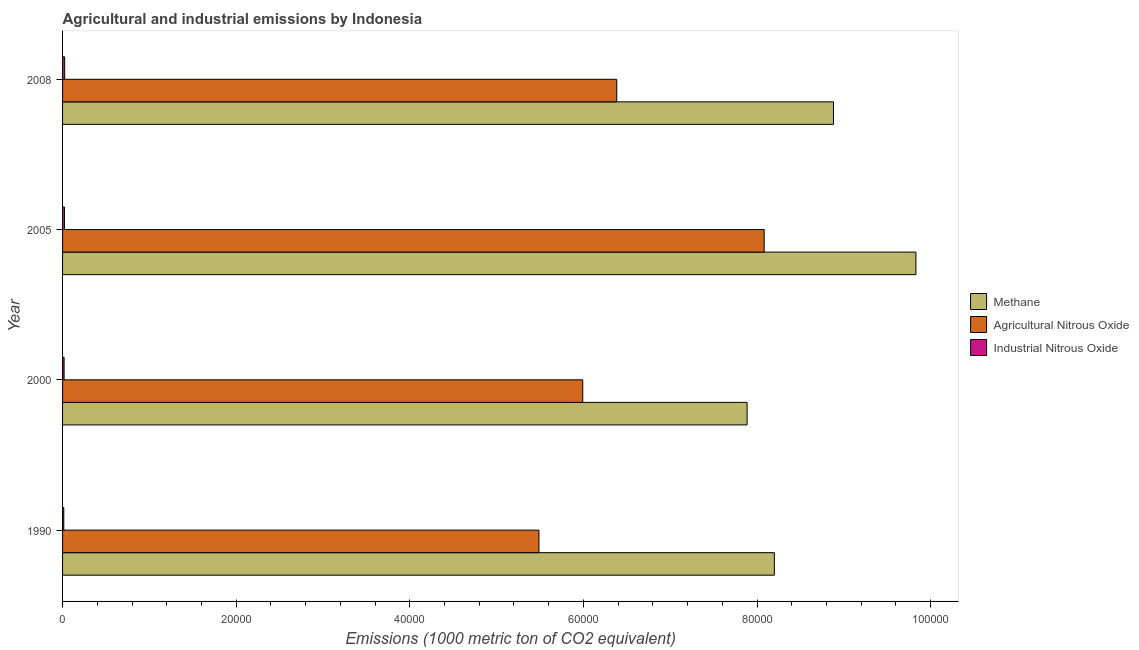How many bars are there on the 3rd tick from the top?
Offer a very short reply. 3. How many bars are there on the 2nd tick from the bottom?
Provide a succinct answer. 3. What is the amount of methane emissions in 2008?
Your answer should be very brief. 8.88e+04. Across all years, what is the maximum amount of industrial nitrous oxide emissions?
Keep it short and to the point. 243.3. Across all years, what is the minimum amount of industrial nitrous oxide emissions?
Make the answer very short. 139.5. In which year was the amount of methane emissions minimum?
Your answer should be very brief. 2000. What is the total amount of methane emissions in the graph?
Your response must be concise. 3.48e+05. What is the difference between the amount of methane emissions in 2000 and that in 2008?
Provide a succinct answer. -9950.5. What is the difference between the amount of agricultural nitrous oxide emissions in 2000 and the amount of industrial nitrous oxide emissions in 2008?
Give a very brief answer. 5.97e+04. What is the average amount of methane emissions per year?
Your answer should be compact. 8.70e+04. In the year 2005, what is the difference between the amount of agricultural nitrous oxide emissions and amount of industrial nitrous oxide emissions?
Provide a short and direct response. 8.06e+04. In how many years, is the amount of methane emissions greater than 76000 metric ton?
Your response must be concise. 4. What is the ratio of the amount of methane emissions in 2000 to that in 2008?
Your answer should be very brief. 0.89. What is the difference between the highest and the second highest amount of industrial nitrous oxide emissions?
Your answer should be compact. 23.7. What is the difference between the highest and the lowest amount of industrial nitrous oxide emissions?
Provide a succinct answer. 103.8. In how many years, is the amount of agricultural nitrous oxide emissions greater than the average amount of agricultural nitrous oxide emissions taken over all years?
Ensure brevity in your answer.  1. Is the sum of the amount of industrial nitrous oxide emissions in 2000 and 2008 greater than the maximum amount of methane emissions across all years?
Offer a terse response. No. What does the 2nd bar from the top in 2005 represents?
Your response must be concise. Agricultural Nitrous Oxide. What does the 3rd bar from the bottom in 2005 represents?
Provide a short and direct response. Industrial Nitrous Oxide. How many years are there in the graph?
Your answer should be compact. 4. Where does the legend appear in the graph?
Give a very brief answer. Center right. What is the title of the graph?
Make the answer very short. Agricultural and industrial emissions by Indonesia. What is the label or title of the X-axis?
Provide a short and direct response. Emissions (1000 metric ton of CO2 equivalent). What is the Emissions (1000 metric ton of CO2 equivalent) of Methane in 1990?
Keep it short and to the point. 8.20e+04. What is the Emissions (1000 metric ton of CO2 equivalent) of Agricultural Nitrous Oxide in 1990?
Your answer should be compact. 5.49e+04. What is the Emissions (1000 metric ton of CO2 equivalent) in Industrial Nitrous Oxide in 1990?
Offer a terse response. 139.5. What is the Emissions (1000 metric ton of CO2 equivalent) in Methane in 2000?
Provide a short and direct response. 7.89e+04. What is the Emissions (1000 metric ton of CO2 equivalent) in Agricultural Nitrous Oxide in 2000?
Offer a terse response. 5.99e+04. What is the Emissions (1000 metric ton of CO2 equivalent) in Industrial Nitrous Oxide in 2000?
Your response must be concise. 175.8. What is the Emissions (1000 metric ton of CO2 equivalent) in Methane in 2005?
Keep it short and to the point. 9.83e+04. What is the Emissions (1000 metric ton of CO2 equivalent) in Agricultural Nitrous Oxide in 2005?
Provide a succinct answer. 8.08e+04. What is the Emissions (1000 metric ton of CO2 equivalent) of Industrial Nitrous Oxide in 2005?
Keep it short and to the point. 219.6. What is the Emissions (1000 metric ton of CO2 equivalent) in Methane in 2008?
Provide a succinct answer. 8.88e+04. What is the Emissions (1000 metric ton of CO2 equivalent) of Agricultural Nitrous Oxide in 2008?
Keep it short and to the point. 6.38e+04. What is the Emissions (1000 metric ton of CO2 equivalent) of Industrial Nitrous Oxide in 2008?
Your answer should be very brief. 243.3. Across all years, what is the maximum Emissions (1000 metric ton of CO2 equivalent) in Methane?
Your answer should be compact. 9.83e+04. Across all years, what is the maximum Emissions (1000 metric ton of CO2 equivalent) of Agricultural Nitrous Oxide?
Give a very brief answer. 8.08e+04. Across all years, what is the maximum Emissions (1000 metric ton of CO2 equivalent) in Industrial Nitrous Oxide?
Provide a short and direct response. 243.3. Across all years, what is the minimum Emissions (1000 metric ton of CO2 equivalent) of Methane?
Provide a short and direct response. 7.89e+04. Across all years, what is the minimum Emissions (1000 metric ton of CO2 equivalent) of Agricultural Nitrous Oxide?
Offer a very short reply. 5.49e+04. Across all years, what is the minimum Emissions (1000 metric ton of CO2 equivalent) of Industrial Nitrous Oxide?
Make the answer very short. 139.5. What is the total Emissions (1000 metric ton of CO2 equivalent) in Methane in the graph?
Give a very brief answer. 3.48e+05. What is the total Emissions (1000 metric ton of CO2 equivalent) of Agricultural Nitrous Oxide in the graph?
Your response must be concise. 2.59e+05. What is the total Emissions (1000 metric ton of CO2 equivalent) in Industrial Nitrous Oxide in the graph?
Make the answer very short. 778.2. What is the difference between the Emissions (1000 metric ton of CO2 equivalent) in Methane in 1990 and that in 2000?
Make the answer very short. 3136.2. What is the difference between the Emissions (1000 metric ton of CO2 equivalent) in Agricultural Nitrous Oxide in 1990 and that in 2000?
Give a very brief answer. -5044.7. What is the difference between the Emissions (1000 metric ton of CO2 equivalent) of Industrial Nitrous Oxide in 1990 and that in 2000?
Provide a succinct answer. -36.3. What is the difference between the Emissions (1000 metric ton of CO2 equivalent) of Methane in 1990 and that in 2005?
Make the answer very short. -1.63e+04. What is the difference between the Emissions (1000 metric ton of CO2 equivalent) of Agricultural Nitrous Oxide in 1990 and that in 2005?
Offer a terse response. -2.59e+04. What is the difference between the Emissions (1000 metric ton of CO2 equivalent) of Industrial Nitrous Oxide in 1990 and that in 2005?
Your response must be concise. -80.1. What is the difference between the Emissions (1000 metric ton of CO2 equivalent) of Methane in 1990 and that in 2008?
Provide a succinct answer. -6814.3. What is the difference between the Emissions (1000 metric ton of CO2 equivalent) in Agricultural Nitrous Oxide in 1990 and that in 2008?
Keep it short and to the point. -8962.8. What is the difference between the Emissions (1000 metric ton of CO2 equivalent) of Industrial Nitrous Oxide in 1990 and that in 2008?
Offer a very short reply. -103.8. What is the difference between the Emissions (1000 metric ton of CO2 equivalent) of Methane in 2000 and that in 2005?
Make the answer very short. -1.94e+04. What is the difference between the Emissions (1000 metric ton of CO2 equivalent) of Agricultural Nitrous Oxide in 2000 and that in 2005?
Your answer should be compact. -2.09e+04. What is the difference between the Emissions (1000 metric ton of CO2 equivalent) of Industrial Nitrous Oxide in 2000 and that in 2005?
Your response must be concise. -43.8. What is the difference between the Emissions (1000 metric ton of CO2 equivalent) of Methane in 2000 and that in 2008?
Provide a succinct answer. -9950.5. What is the difference between the Emissions (1000 metric ton of CO2 equivalent) of Agricultural Nitrous Oxide in 2000 and that in 2008?
Your response must be concise. -3918.1. What is the difference between the Emissions (1000 metric ton of CO2 equivalent) of Industrial Nitrous Oxide in 2000 and that in 2008?
Give a very brief answer. -67.5. What is the difference between the Emissions (1000 metric ton of CO2 equivalent) in Methane in 2005 and that in 2008?
Make the answer very short. 9496.1. What is the difference between the Emissions (1000 metric ton of CO2 equivalent) of Agricultural Nitrous Oxide in 2005 and that in 2008?
Your answer should be very brief. 1.70e+04. What is the difference between the Emissions (1000 metric ton of CO2 equivalent) of Industrial Nitrous Oxide in 2005 and that in 2008?
Offer a very short reply. -23.7. What is the difference between the Emissions (1000 metric ton of CO2 equivalent) in Methane in 1990 and the Emissions (1000 metric ton of CO2 equivalent) in Agricultural Nitrous Oxide in 2000?
Offer a terse response. 2.21e+04. What is the difference between the Emissions (1000 metric ton of CO2 equivalent) of Methane in 1990 and the Emissions (1000 metric ton of CO2 equivalent) of Industrial Nitrous Oxide in 2000?
Provide a short and direct response. 8.18e+04. What is the difference between the Emissions (1000 metric ton of CO2 equivalent) in Agricultural Nitrous Oxide in 1990 and the Emissions (1000 metric ton of CO2 equivalent) in Industrial Nitrous Oxide in 2000?
Make the answer very short. 5.47e+04. What is the difference between the Emissions (1000 metric ton of CO2 equivalent) of Methane in 1990 and the Emissions (1000 metric ton of CO2 equivalent) of Agricultural Nitrous Oxide in 2005?
Provide a short and direct response. 1171.4. What is the difference between the Emissions (1000 metric ton of CO2 equivalent) of Methane in 1990 and the Emissions (1000 metric ton of CO2 equivalent) of Industrial Nitrous Oxide in 2005?
Keep it short and to the point. 8.18e+04. What is the difference between the Emissions (1000 metric ton of CO2 equivalent) of Agricultural Nitrous Oxide in 1990 and the Emissions (1000 metric ton of CO2 equivalent) of Industrial Nitrous Oxide in 2005?
Offer a very short reply. 5.47e+04. What is the difference between the Emissions (1000 metric ton of CO2 equivalent) of Methane in 1990 and the Emissions (1000 metric ton of CO2 equivalent) of Agricultural Nitrous Oxide in 2008?
Your answer should be very brief. 1.82e+04. What is the difference between the Emissions (1000 metric ton of CO2 equivalent) in Methane in 1990 and the Emissions (1000 metric ton of CO2 equivalent) in Industrial Nitrous Oxide in 2008?
Provide a short and direct response. 8.18e+04. What is the difference between the Emissions (1000 metric ton of CO2 equivalent) of Agricultural Nitrous Oxide in 1990 and the Emissions (1000 metric ton of CO2 equivalent) of Industrial Nitrous Oxide in 2008?
Provide a short and direct response. 5.46e+04. What is the difference between the Emissions (1000 metric ton of CO2 equivalent) in Methane in 2000 and the Emissions (1000 metric ton of CO2 equivalent) in Agricultural Nitrous Oxide in 2005?
Keep it short and to the point. -1964.8. What is the difference between the Emissions (1000 metric ton of CO2 equivalent) in Methane in 2000 and the Emissions (1000 metric ton of CO2 equivalent) in Industrial Nitrous Oxide in 2005?
Keep it short and to the point. 7.86e+04. What is the difference between the Emissions (1000 metric ton of CO2 equivalent) in Agricultural Nitrous Oxide in 2000 and the Emissions (1000 metric ton of CO2 equivalent) in Industrial Nitrous Oxide in 2005?
Provide a succinct answer. 5.97e+04. What is the difference between the Emissions (1000 metric ton of CO2 equivalent) in Methane in 2000 and the Emissions (1000 metric ton of CO2 equivalent) in Agricultural Nitrous Oxide in 2008?
Your answer should be very brief. 1.50e+04. What is the difference between the Emissions (1000 metric ton of CO2 equivalent) in Methane in 2000 and the Emissions (1000 metric ton of CO2 equivalent) in Industrial Nitrous Oxide in 2008?
Ensure brevity in your answer.  7.86e+04. What is the difference between the Emissions (1000 metric ton of CO2 equivalent) in Agricultural Nitrous Oxide in 2000 and the Emissions (1000 metric ton of CO2 equivalent) in Industrial Nitrous Oxide in 2008?
Your answer should be compact. 5.97e+04. What is the difference between the Emissions (1000 metric ton of CO2 equivalent) of Methane in 2005 and the Emissions (1000 metric ton of CO2 equivalent) of Agricultural Nitrous Oxide in 2008?
Your answer should be compact. 3.45e+04. What is the difference between the Emissions (1000 metric ton of CO2 equivalent) in Methane in 2005 and the Emissions (1000 metric ton of CO2 equivalent) in Industrial Nitrous Oxide in 2008?
Your answer should be compact. 9.81e+04. What is the difference between the Emissions (1000 metric ton of CO2 equivalent) in Agricultural Nitrous Oxide in 2005 and the Emissions (1000 metric ton of CO2 equivalent) in Industrial Nitrous Oxide in 2008?
Your response must be concise. 8.06e+04. What is the average Emissions (1000 metric ton of CO2 equivalent) of Methane per year?
Your answer should be very brief. 8.70e+04. What is the average Emissions (1000 metric ton of CO2 equivalent) of Agricultural Nitrous Oxide per year?
Provide a succinct answer. 6.49e+04. What is the average Emissions (1000 metric ton of CO2 equivalent) of Industrial Nitrous Oxide per year?
Provide a short and direct response. 194.55. In the year 1990, what is the difference between the Emissions (1000 metric ton of CO2 equivalent) in Methane and Emissions (1000 metric ton of CO2 equivalent) in Agricultural Nitrous Oxide?
Offer a very short reply. 2.71e+04. In the year 1990, what is the difference between the Emissions (1000 metric ton of CO2 equivalent) in Methane and Emissions (1000 metric ton of CO2 equivalent) in Industrial Nitrous Oxide?
Your answer should be compact. 8.19e+04. In the year 1990, what is the difference between the Emissions (1000 metric ton of CO2 equivalent) in Agricultural Nitrous Oxide and Emissions (1000 metric ton of CO2 equivalent) in Industrial Nitrous Oxide?
Provide a succinct answer. 5.47e+04. In the year 2000, what is the difference between the Emissions (1000 metric ton of CO2 equivalent) in Methane and Emissions (1000 metric ton of CO2 equivalent) in Agricultural Nitrous Oxide?
Make the answer very short. 1.89e+04. In the year 2000, what is the difference between the Emissions (1000 metric ton of CO2 equivalent) in Methane and Emissions (1000 metric ton of CO2 equivalent) in Industrial Nitrous Oxide?
Give a very brief answer. 7.87e+04. In the year 2000, what is the difference between the Emissions (1000 metric ton of CO2 equivalent) in Agricultural Nitrous Oxide and Emissions (1000 metric ton of CO2 equivalent) in Industrial Nitrous Oxide?
Offer a very short reply. 5.98e+04. In the year 2005, what is the difference between the Emissions (1000 metric ton of CO2 equivalent) of Methane and Emissions (1000 metric ton of CO2 equivalent) of Agricultural Nitrous Oxide?
Give a very brief answer. 1.75e+04. In the year 2005, what is the difference between the Emissions (1000 metric ton of CO2 equivalent) in Methane and Emissions (1000 metric ton of CO2 equivalent) in Industrial Nitrous Oxide?
Your response must be concise. 9.81e+04. In the year 2005, what is the difference between the Emissions (1000 metric ton of CO2 equivalent) of Agricultural Nitrous Oxide and Emissions (1000 metric ton of CO2 equivalent) of Industrial Nitrous Oxide?
Your answer should be compact. 8.06e+04. In the year 2008, what is the difference between the Emissions (1000 metric ton of CO2 equivalent) in Methane and Emissions (1000 metric ton of CO2 equivalent) in Agricultural Nitrous Oxide?
Give a very brief answer. 2.50e+04. In the year 2008, what is the difference between the Emissions (1000 metric ton of CO2 equivalent) of Methane and Emissions (1000 metric ton of CO2 equivalent) of Industrial Nitrous Oxide?
Keep it short and to the point. 8.86e+04. In the year 2008, what is the difference between the Emissions (1000 metric ton of CO2 equivalent) in Agricultural Nitrous Oxide and Emissions (1000 metric ton of CO2 equivalent) in Industrial Nitrous Oxide?
Offer a very short reply. 6.36e+04. What is the ratio of the Emissions (1000 metric ton of CO2 equivalent) in Methane in 1990 to that in 2000?
Keep it short and to the point. 1.04. What is the ratio of the Emissions (1000 metric ton of CO2 equivalent) in Agricultural Nitrous Oxide in 1990 to that in 2000?
Your answer should be compact. 0.92. What is the ratio of the Emissions (1000 metric ton of CO2 equivalent) of Industrial Nitrous Oxide in 1990 to that in 2000?
Offer a terse response. 0.79. What is the ratio of the Emissions (1000 metric ton of CO2 equivalent) of Methane in 1990 to that in 2005?
Keep it short and to the point. 0.83. What is the ratio of the Emissions (1000 metric ton of CO2 equivalent) in Agricultural Nitrous Oxide in 1990 to that in 2005?
Keep it short and to the point. 0.68. What is the ratio of the Emissions (1000 metric ton of CO2 equivalent) of Industrial Nitrous Oxide in 1990 to that in 2005?
Provide a short and direct response. 0.64. What is the ratio of the Emissions (1000 metric ton of CO2 equivalent) of Methane in 1990 to that in 2008?
Ensure brevity in your answer.  0.92. What is the ratio of the Emissions (1000 metric ton of CO2 equivalent) of Agricultural Nitrous Oxide in 1990 to that in 2008?
Offer a terse response. 0.86. What is the ratio of the Emissions (1000 metric ton of CO2 equivalent) of Industrial Nitrous Oxide in 1990 to that in 2008?
Your answer should be very brief. 0.57. What is the ratio of the Emissions (1000 metric ton of CO2 equivalent) in Methane in 2000 to that in 2005?
Offer a terse response. 0.8. What is the ratio of the Emissions (1000 metric ton of CO2 equivalent) of Agricultural Nitrous Oxide in 2000 to that in 2005?
Offer a terse response. 0.74. What is the ratio of the Emissions (1000 metric ton of CO2 equivalent) of Industrial Nitrous Oxide in 2000 to that in 2005?
Make the answer very short. 0.8. What is the ratio of the Emissions (1000 metric ton of CO2 equivalent) of Methane in 2000 to that in 2008?
Make the answer very short. 0.89. What is the ratio of the Emissions (1000 metric ton of CO2 equivalent) of Agricultural Nitrous Oxide in 2000 to that in 2008?
Your response must be concise. 0.94. What is the ratio of the Emissions (1000 metric ton of CO2 equivalent) in Industrial Nitrous Oxide in 2000 to that in 2008?
Offer a terse response. 0.72. What is the ratio of the Emissions (1000 metric ton of CO2 equivalent) in Methane in 2005 to that in 2008?
Offer a very short reply. 1.11. What is the ratio of the Emissions (1000 metric ton of CO2 equivalent) in Agricultural Nitrous Oxide in 2005 to that in 2008?
Give a very brief answer. 1.27. What is the ratio of the Emissions (1000 metric ton of CO2 equivalent) of Industrial Nitrous Oxide in 2005 to that in 2008?
Keep it short and to the point. 0.9. What is the difference between the highest and the second highest Emissions (1000 metric ton of CO2 equivalent) of Methane?
Your response must be concise. 9496.1. What is the difference between the highest and the second highest Emissions (1000 metric ton of CO2 equivalent) in Agricultural Nitrous Oxide?
Your response must be concise. 1.70e+04. What is the difference between the highest and the second highest Emissions (1000 metric ton of CO2 equivalent) in Industrial Nitrous Oxide?
Keep it short and to the point. 23.7. What is the difference between the highest and the lowest Emissions (1000 metric ton of CO2 equivalent) of Methane?
Provide a short and direct response. 1.94e+04. What is the difference between the highest and the lowest Emissions (1000 metric ton of CO2 equivalent) of Agricultural Nitrous Oxide?
Ensure brevity in your answer.  2.59e+04. What is the difference between the highest and the lowest Emissions (1000 metric ton of CO2 equivalent) in Industrial Nitrous Oxide?
Your response must be concise. 103.8. 